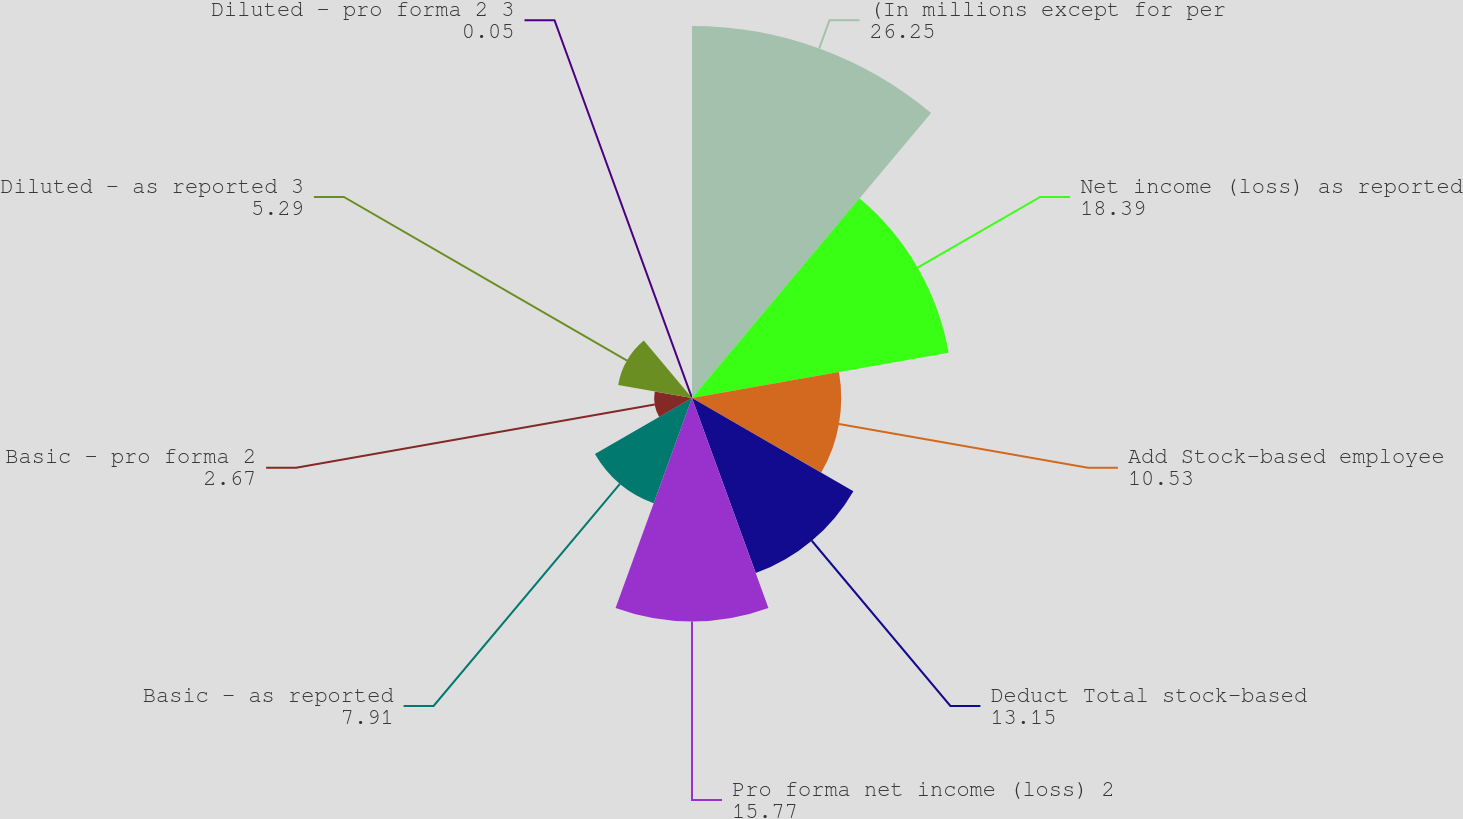Convert chart to OTSL. <chart><loc_0><loc_0><loc_500><loc_500><pie_chart><fcel>(In millions except for per<fcel>Net income (loss) as reported<fcel>Add Stock-based employee<fcel>Deduct Total stock-based<fcel>Pro forma net income (loss) 2<fcel>Basic - as reported<fcel>Basic - pro forma 2<fcel>Diluted - as reported 3<fcel>Diluted - pro forma 2 3<nl><fcel>26.25%<fcel>18.39%<fcel>10.53%<fcel>13.15%<fcel>15.77%<fcel>7.91%<fcel>2.67%<fcel>5.29%<fcel>0.05%<nl></chart> 